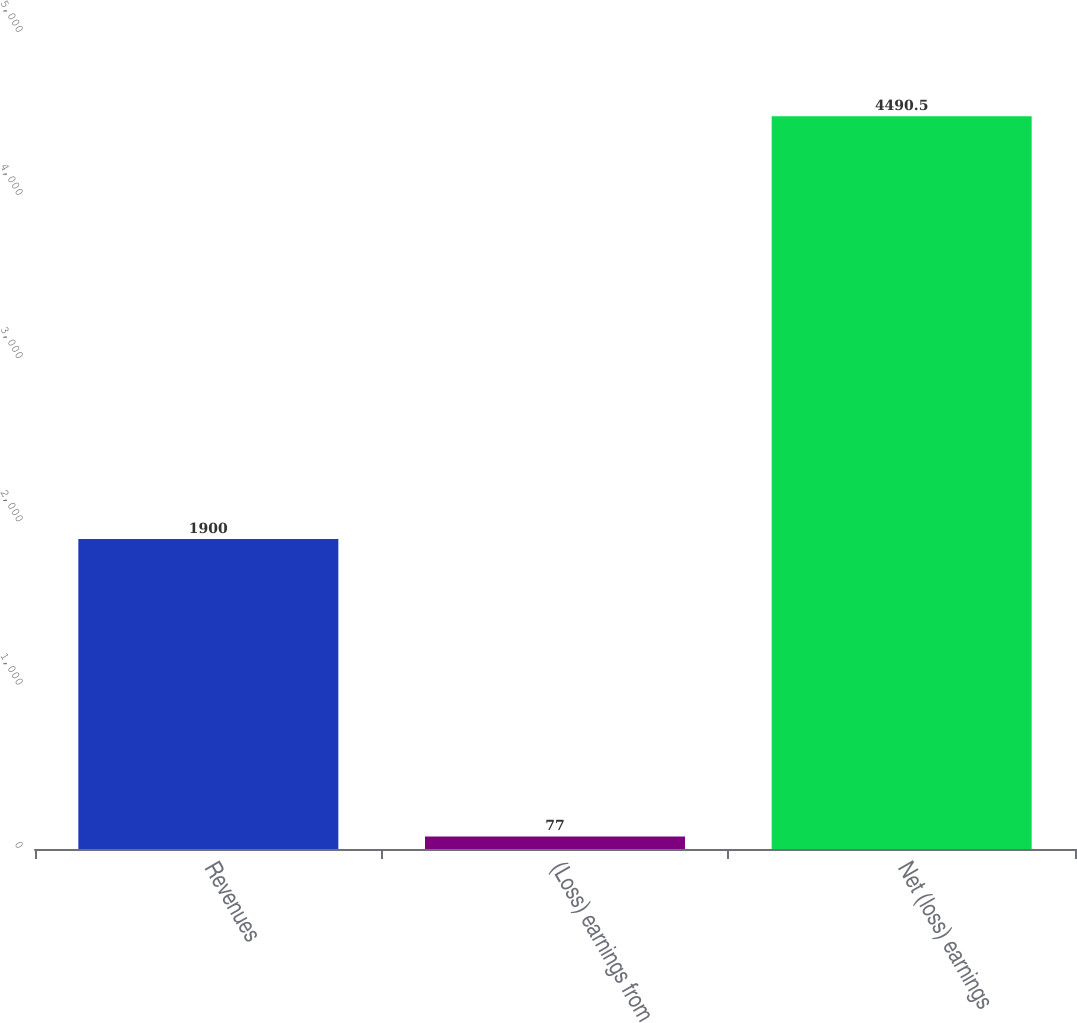Convert chart to OTSL. <chart><loc_0><loc_0><loc_500><loc_500><bar_chart><fcel>Revenues<fcel>(Loss) earnings from<fcel>Net (loss) earnings<nl><fcel>1900<fcel>77<fcel>4490.5<nl></chart> 